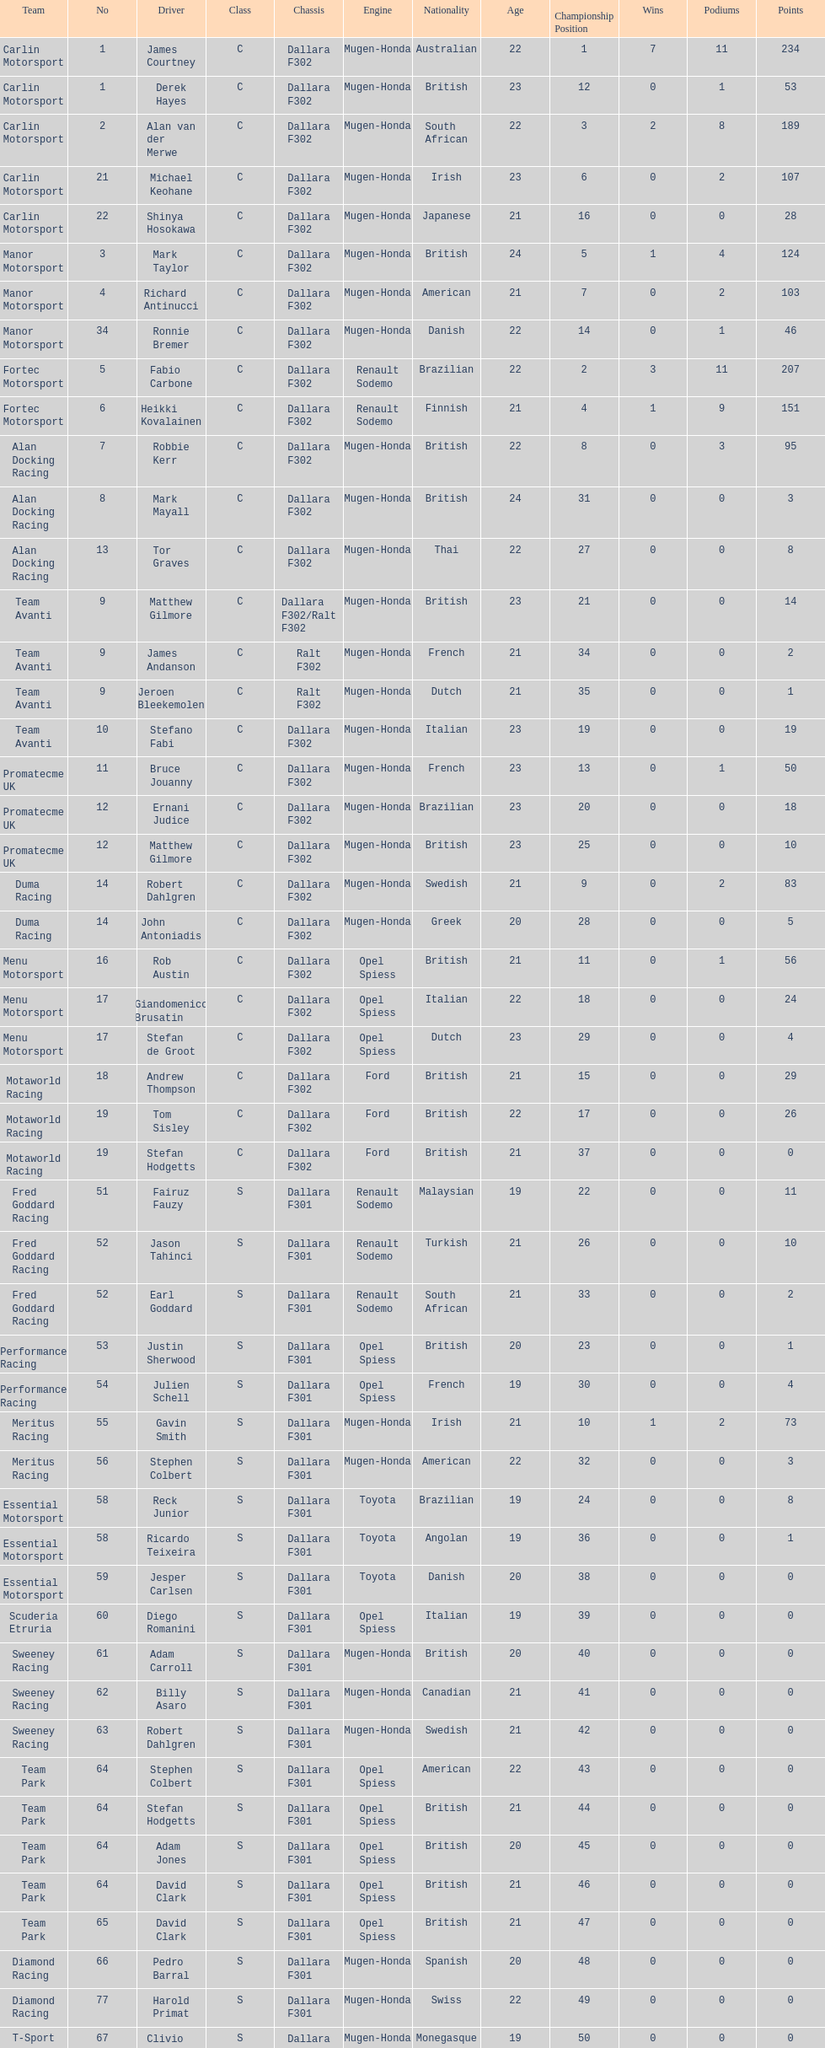What team is listed above diamond racing? Team Park. I'm looking to parse the entire table for insights. Could you assist me with that? {'header': ['Team', 'No', 'Driver', 'Class', 'Chassis', 'Engine', 'Nationality', 'Age', 'Championship Position', 'Wins', 'Podiums', 'Points'], 'rows': [['Carlin Motorsport', '1', 'James Courtney', 'C', 'Dallara F302', 'Mugen-Honda', 'Australian', '22', '1', '7', '11', '234'], ['Carlin Motorsport', '1', 'Derek Hayes', 'C', 'Dallara F302', 'Mugen-Honda', 'British', '23', '12', '0', '1', '53'], ['Carlin Motorsport', '2', 'Alan van der Merwe', 'C', 'Dallara F302', 'Mugen-Honda', 'South African', '22', '3', '2', '8', '189'], ['Carlin Motorsport', '21', 'Michael Keohane', 'C', 'Dallara F302', 'Mugen-Honda', 'Irish', '23', '6', '0', '2', '107'], ['Carlin Motorsport', '22', 'Shinya Hosokawa', 'C', 'Dallara F302', 'Mugen-Honda', 'Japanese', '21', '16', '0', '0', '28'], ['Manor Motorsport', '3', 'Mark Taylor', 'C', 'Dallara F302', 'Mugen-Honda', 'British', '24', '5', '1', '4', '124'], ['Manor Motorsport', '4', 'Richard Antinucci', 'C', 'Dallara F302', 'Mugen-Honda', 'American', '21', '7', '0', '2', '103'], ['Manor Motorsport', '34', 'Ronnie Bremer', 'C', 'Dallara F302', 'Mugen-Honda', 'Danish', '22', '14', '0', '1', '46'], ['Fortec Motorsport', '5', 'Fabio Carbone', 'C', 'Dallara F302', 'Renault Sodemo', 'Brazilian', '22', '2', '3', '11', '207'], ['Fortec Motorsport', '6', 'Heikki Kovalainen', 'C', 'Dallara F302', 'Renault Sodemo', 'Finnish', '21', '4', '1', '9', '151'], ['Alan Docking Racing', '7', 'Robbie Kerr', 'C', 'Dallara F302', 'Mugen-Honda', 'British', '22', '8', '0', '3', '95'], ['Alan Docking Racing', '8', 'Mark Mayall', 'C', 'Dallara F302', 'Mugen-Honda', 'British', '24', '31', '0', '0', '3'], ['Alan Docking Racing', '13', 'Tor Graves', 'C', 'Dallara F302', 'Mugen-Honda', 'Thai', '22', '27', '0', '0', '8'], ['Team Avanti', '9', 'Matthew Gilmore', 'C', 'Dallara F302/Ralt F302', 'Mugen-Honda', 'British', '23', '21', '0', '0', '14'], ['Team Avanti', '9', 'James Andanson', 'C', 'Ralt F302', 'Mugen-Honda', 'French', '21', '34', '0', '0', '2'], ['Team Avanti', '9', 'Jeroen Bleekemolen', 'C', 'Ralt F302', 'Mugen-Honda', 'Dutch', '21', '35', '0', '0', '1'], ['Team Avanti', '10', 'Stefano Fabi', 'C', 'Dallara F302', 'Mugen-Honda', 'Italian', '23', '19', '0', '0', '19'], ['Promatecme UK', '11', 'Bruce Jouanny', 'C', 'Dallara F302', 'Mugen-Honda', 'French', '23', '13', '0', '1', '50'], ['Promatecme UK', '12', 'Ernani Judice', 'C', 'Dallara F302', 'Mugen-Honda', 'Brazilian', '23', '20', '0', '0', '18'], ['Promatecme UK', '12', 'Matthew Gilmore', 'C', 'Dallara F302', 'Mugen-Honda', 'British', '23', '25', '0', '0', '10'], ['Duma Racing', '14', 'Robert Dahlgren', 'C', 'Dallara F302', 'Mugen-Honda', 'Swedish', '21', '9', '0', '2', '83'], ['Duma Racing', '14', 'John Antoniadis', 'C', 'Dallara F302', 'Mugen-Honda', 'Greek', '20', '28', '0', '0', '5'], ['Menu Motorsport', '16', 'Rob Austin', 'C', 'Dallara F302', 'Opel Spiess', 'British', '21', '11', '0', '1', '56'], ['Menu Motorsport', '17', 'Giandomenico Brusatin', 'C', 'Dallara F302', 'Opel Spiess', 'Italian', '22', '18', '0', '0', '24'], ['Menu Motorsport', '17', 'Stefan de Groot', 'C', 'Dallara F302', 'Opel Spiess', 'Dutch', '23', '29', '0', '0', '4'], ['Motaworld Racing', '18', 'Andrew Thompson', 'C', 'Dallara F302', 'Ford', 'British', '21', '15', '0', '0', '29'], ['Motaworld Racing', '19', 'Tom Sisley', 'C', 'Dallara F302', 'Ford', 'British', '22', '17', '0', '0', '26'], ['Motaworld Racing', '19', 'Stefan Hodgetts', 'C', 'Dallara F302', 'Ford', 'British', '21', '37', '0', '0', '0'], ['Fred Goddard Racing', '51', 'Fairuz Fauzy', 'S', 'Dallara F301', 'Renault Sodemo', 'Malaysian', '19', '22', '0', '0', '11'], ['Fred Goddard Racing', '52', 'Jason Tahinci', 'S', 'Dallara F301', 'Renault Sodemo', 'Turkish', '21', '26', '0', '0', '10'], ['Fred Goddard Racing', '52', 'Earl Goddard', 'S', 'Dallara F301', 'Renault Sodemo', 'South African', '21', '33', '0', '0', '2'], ['Performance Racing', '53', 'Justin Sherwood', 'S', 'Dallara F301', 'Opel Spiess', 'British', '20', '23', '0', '0', '1'], ['Performance Racing', '54', 'Julien Schell', 'S', 'Dallara F301', 'Opel Spiess', 'French', '19', '30', '0', '0', '4'], ['Meritus Racing', '55', 'Gavin Smith', 'S', 'Dallara F301', 'Mugen-Honda', 'Irish', '21', '10', '1', '2', '73'], ['Meritus Racing', '56', 'Stephen Colbert', 'S', 'Dallara F301', 'Mugen-Honda', 'American', '22', '32', '0', '0', '3'], ['Essential Motorsport', '58', 'Reck Junior', 'S', 'Dallara F301', 'Toyota', 'Brazilian', '19', '24', '0', '0', '8'], ['Essential Motorsport', '58', 'Ricardo Teixeira', 'S', 'Dallara F301', 'Toyota', 'Angolan', '19', '36', '0', '0', '1'], ['Essential Motorsport', '59', 'Jesper Carlsen', 'S', 'Dallara F301', 'Toyota', 'Danish', '20', '38', '0', '0', '0'], ['Scuderia Etruria', '60', 'Diego Romanini', 'S', 'Dallara F301', 'Opel Spiess', 'Italian', '19', '39', '0', '0', '0'], ['Sweeney Racing', '61', 'Adam Carroll', 'S', 'Dallara F301', 'Mugen-Honda', 'British', '20', '40', '0', '0', '0'], ['Sweeney Racing', '62', 'Billy Asaro', 'S', 'Dallara F301', 'Mugen-Honda', 'Canadian', '21', '41', '0', '0', '0'], ['Sweeney Racing', '63', 'Robert Dahlgren', 'S', 'Dallara F301', 'Mugen-Honda', 'Swedish', '21', '42', '0', '0', '0'], ['Team Park', '64', 'Stephen Colbert', 'S', 'Dallara F301', 'Opel Spiess', 'American', '22', '43', '0', '0', '0'], ['Team Park', '64', 'Stefan Hodgetts', 'S', 'Dallara F301', 'Opel Spiess', 'British', '21', '44', '0', '0', '0'], ['Team Park', '64', 'Adam Jones', 'S', 'Dallara F301', 'Opel Spiess', 'British', '20', '45', '0', '0', '0'], ['Team Park', '64', 'David Clark', 'S', 'Dallara F301', 'Opel Spiess', 'British', '21', '46', '0', '0', '0'], ['Team Park', '65', 'David Clark', 'S', 'Dallara F301', 'Opel Spiess', 'British', '21', '47', '0', '0', '0'], ['Diamond Racing', '66', 'Pedro Barral', 'S', 'Dallara F301', 'Mugen-Honda', 'Spanish', '20', '48', '0', '0', '0'], ['Diamond Racing', '77', 'Harold Primat', 'S', 'Dallara F301', 'Mugen-Honda', 'Swiss', '22', '49', '0', '0', '0'], ['T-Sport', '67', 'Clivio Piccione', 'S', 'Dallara F301', 'Mugen-Honda', 'Monegasque', '19', '50', '0', '0', '0'], ['T-Sport', '68', 'Karun Chandhok', 'S', 'Dallara F301', 'Mugen-Honda', 'Indian', '18', '51', '0', '0', '0'], ['Hill Speed Motorsport', '69', 'Luke Stevens', 'S', 'Dallara F301', 'Opel Spiess', 'British', '21', '52', '0', '0', '0']]} 